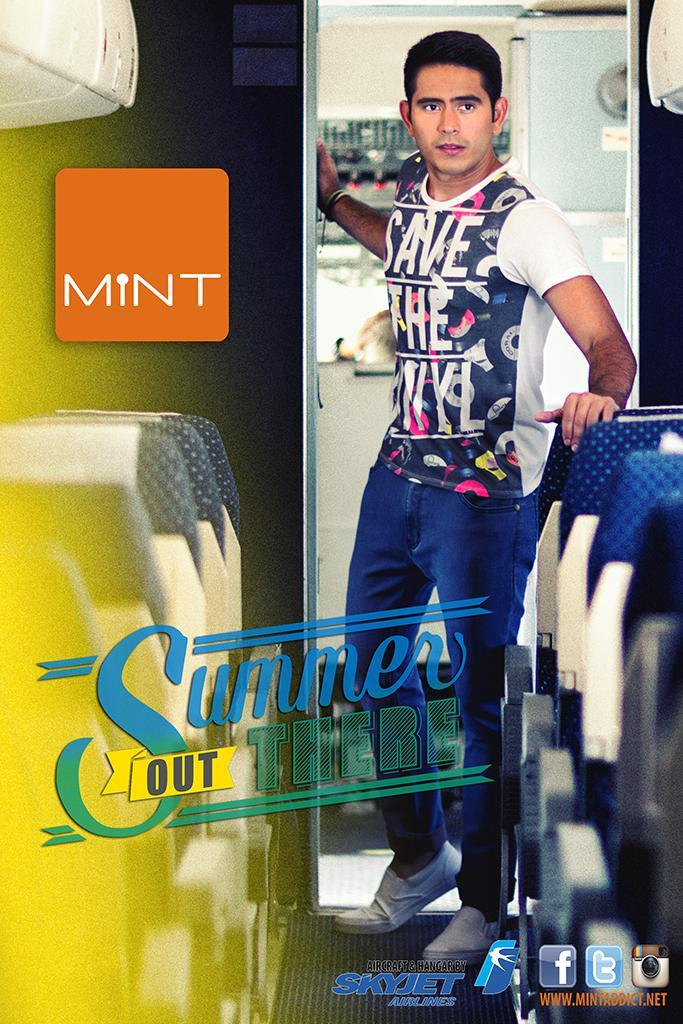<image>
Give a short and clear explanation of the subsequent image. A man stands in a doorway in a poster that mentions Skyjet Airlines. 